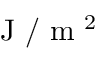Convert formula to latex. <formula><loc_0><loc_0><loc_500><loc_500>J / m ^ { 2 }</formula> 